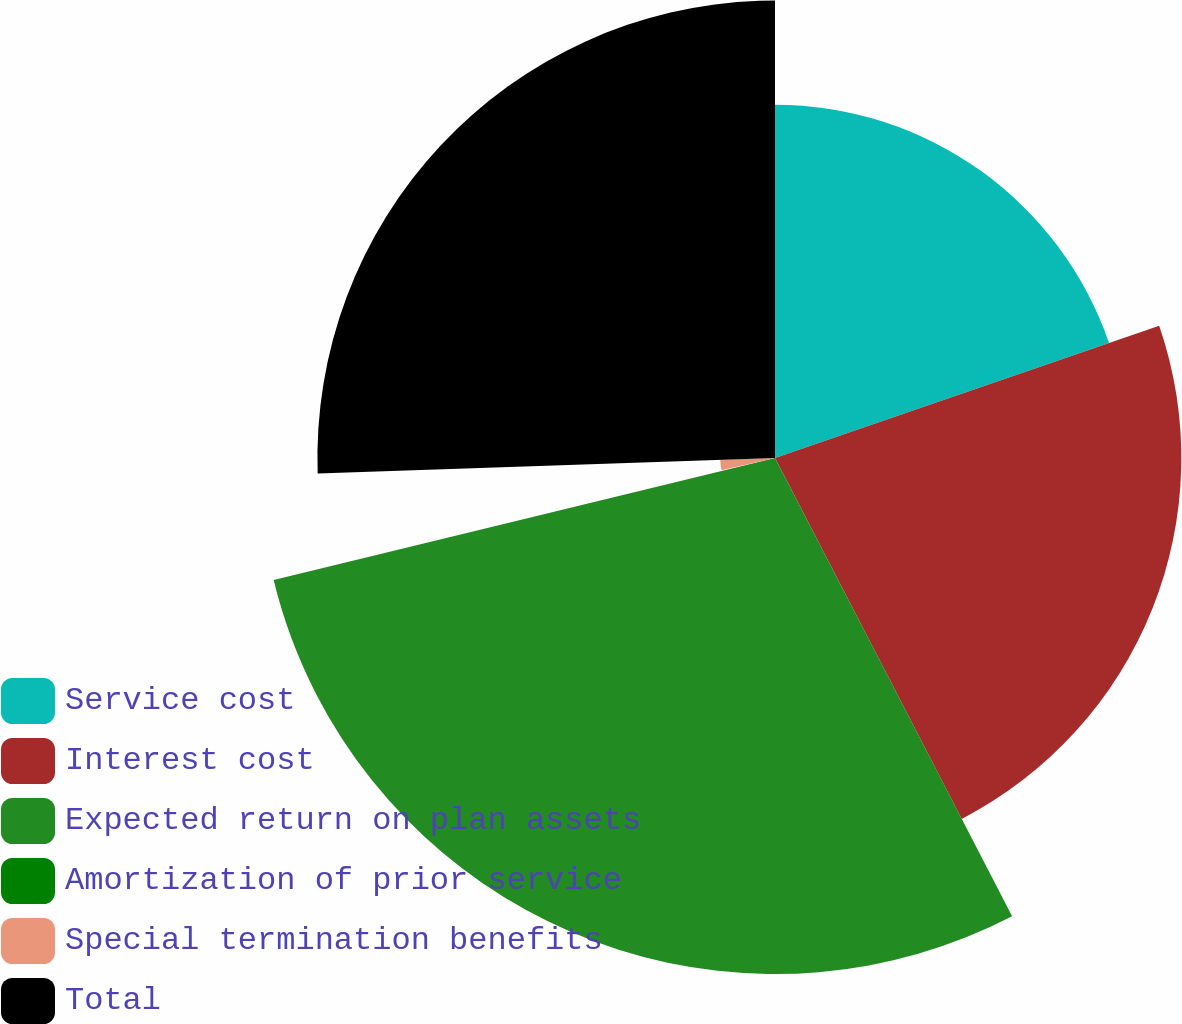Convert chart. <chart><loc_0><loc_0><loc_500><loc_500><pie_chart><fcel>Service cost<fcel>Interest cost<fcel>Expected return on plan assets<fcel>Amortization of prior service<fcel>Special termination benefits<fcel>Total<nl><fcel>19.72%<fcel>22.68%<fcel>28.8%<fcel>0.2%<fcel>3.06%<fcel>25.54%<nl></chart> 